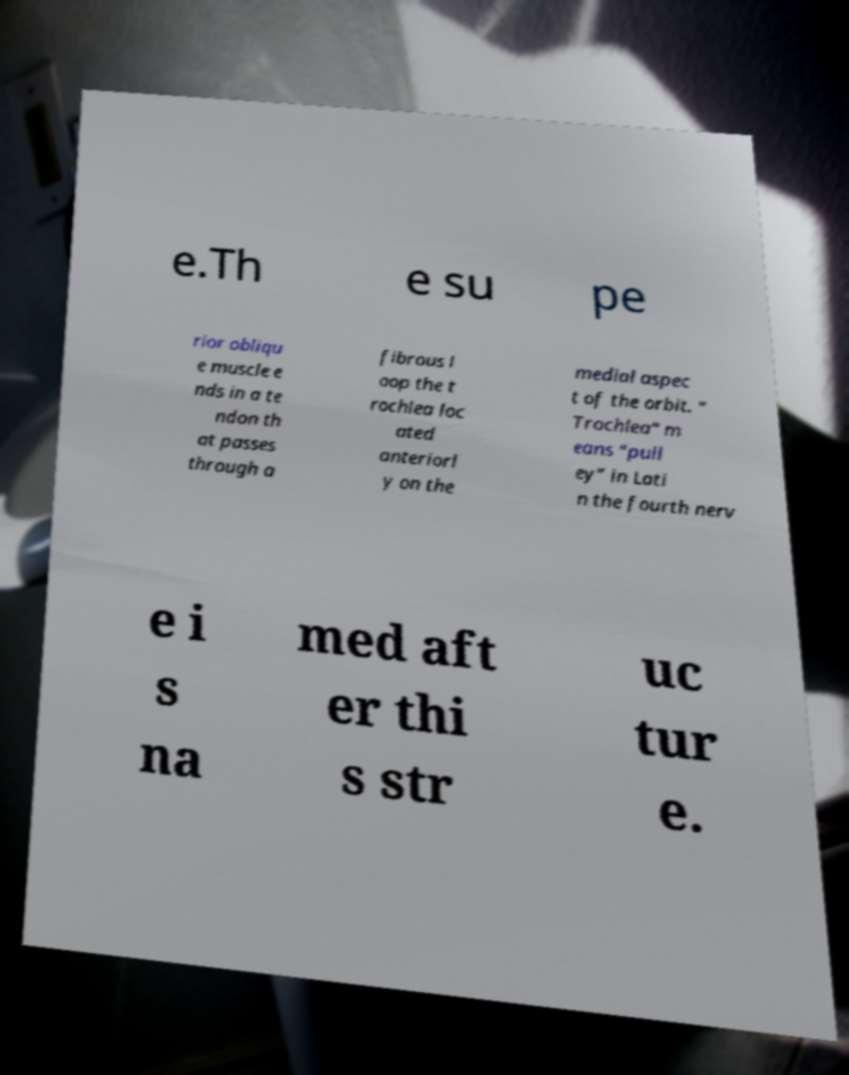For documentation purposes, I need the text within this image transcribed. Could you provide that? e.Th e su pe rior obliqu e muscle e nds in a te ndon th at passes through a fibrous l oop the t rochlea loc ated anteriorl y on the medial aspec t of the orbit. " Trochlea" m eans “pull ey” in Lati n the fourth nerv e i s na med aft er thi s str uc tur e. 